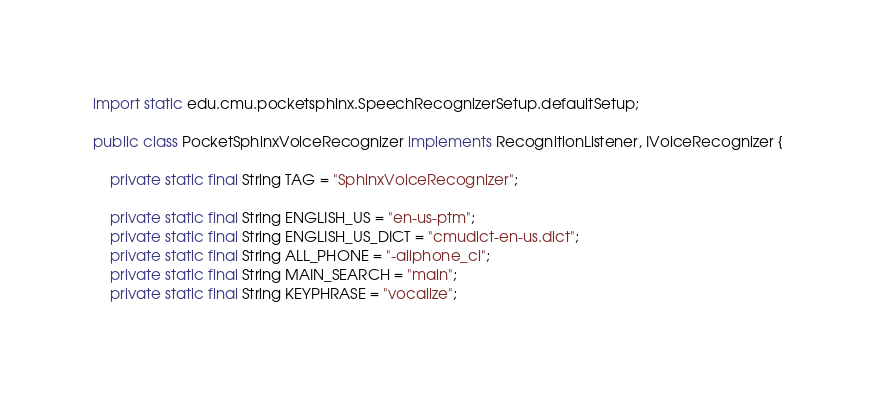Convert code to text. <code><loc_0><loc_0><loc_500><loc_500><_Java_>
import static edu.cmu.pocketsphinx.SpeechRecognizerSetup.defaultSetup;

public class PocketSphinxVoiceRecognizer implements RecognitionListener, IVoiceRecognizer {

    private static final String TAG = "SphinxVoiceRecognizer";

    private static final String ENGLISH_US = "en-us-ptm";
    private static final String ENGLISH_US_DICT = "cmudict-en-us.dict";
    private static final String ALL_PHONE = "-allphone_ci";
    private static final String MAIN_SEARCH = "main";
    private static final String KEYPHRASE = "vocalize";</code> 